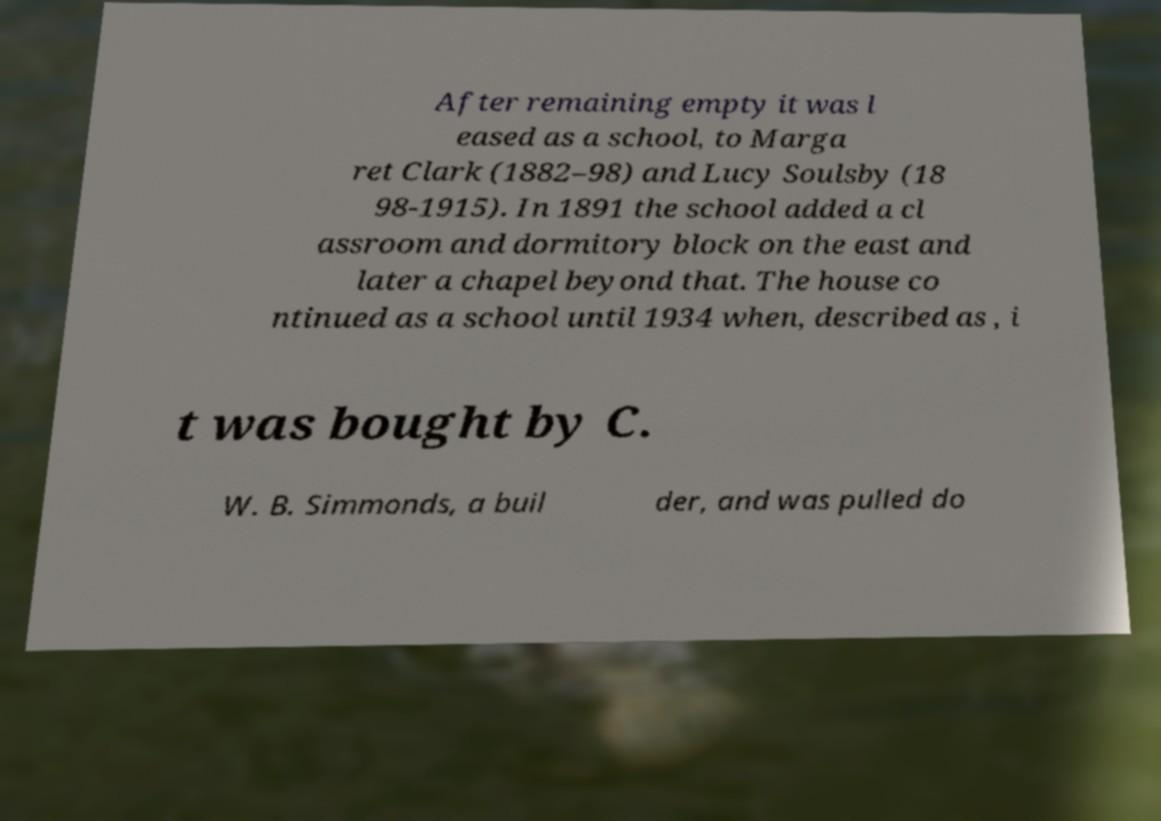Please read and relay the text visible in this image. What does it say? After remaining empty it was l eased as a school, to Marga ret Clark (1882–98) and Lucy Soulsby (18 98-1915). In 1891 the school added a cl assroom and dormitory block on the east and later a chapel beyond that. The house co ntinued as a school until 1934 when, described as , i t was bought by C. W. B. Simmonds, a buil der, and was pulled do 